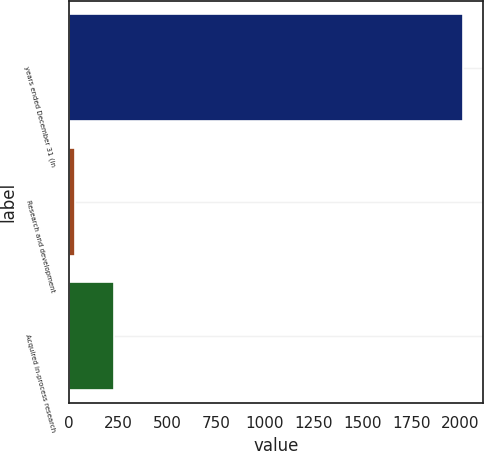<chart> <loc_0><loc_0><loc_500><loc_500><bar_chart><fcel>years ended December 31 (in<fcel>Research and development<fcel>Acquired in-process research<nl><fcel>2015<fcel>30<fcel>228.5<nl></chart> 